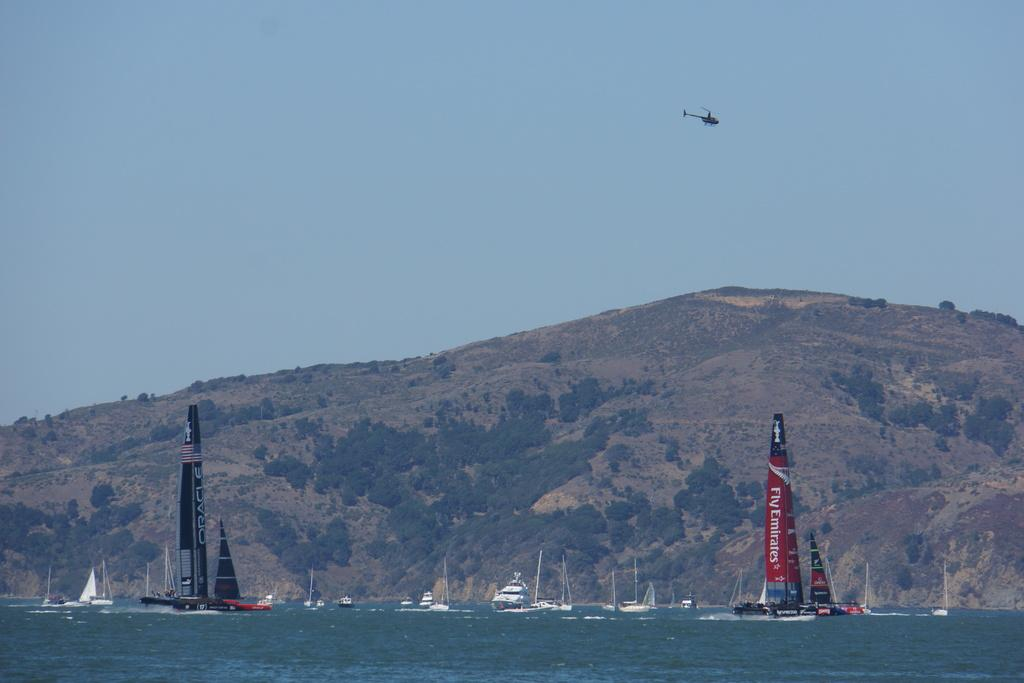<image>
Share a concise interpretation of the image provided. A helicopter flys above a Fly Emirates sail boat in the middle of the water 